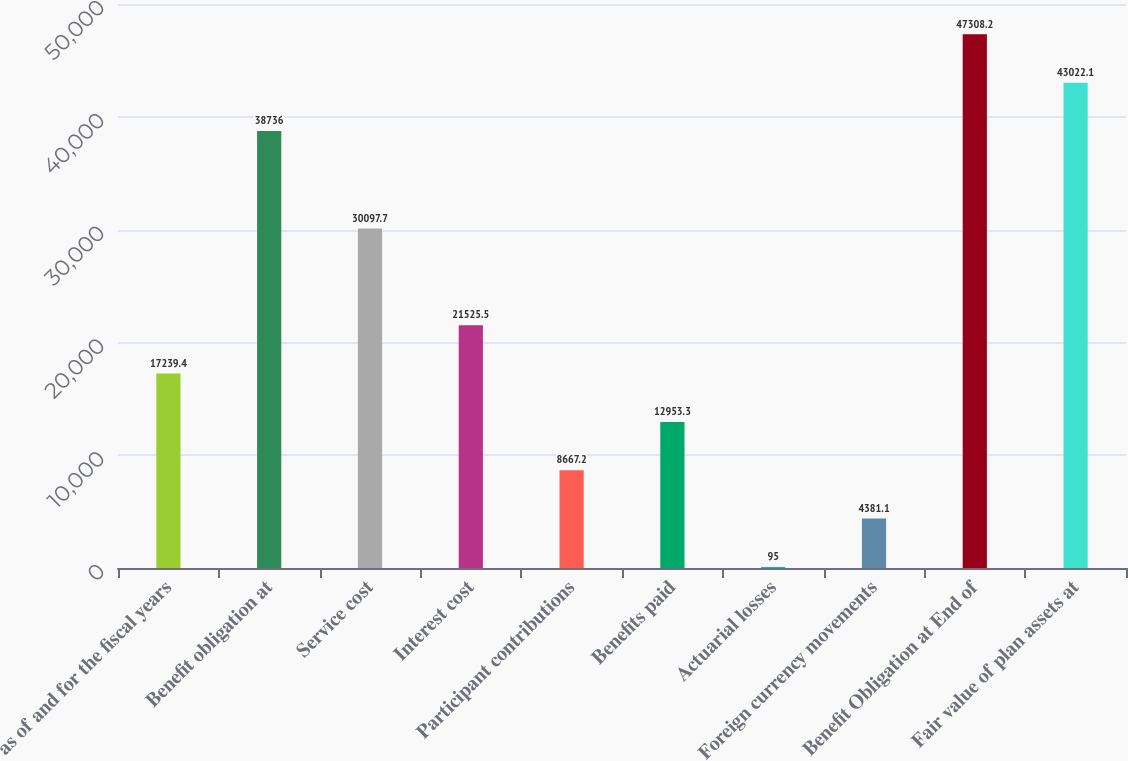Convert chart. <chart><loc_0><loc_0><loc_500><loc_500><bar_chart><fcel>as of and for the fiscal years<fcel>Benefit obligation at<fcel>Service cost<fcel>Interest cost<fcel>Participant contributions<fcel>Benefits paid<fcel>Actuarial losses<fcel>Foreign currency movements<fcel>Benefit Obligation at End of<fcel>Fair value of plan assets at<nl><fcel>17239.4<fcel>38736<fcel>30097.7<fcel>21525.5<fcel>8667.2<fcel>12953.3<fcel>95<fcel>4381.1<fcel>47308.2<fcel>43022.1<nl></chart> 